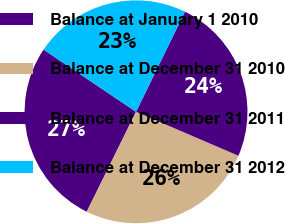Convert chart. <chart><loc_0><loc_0><loc_500><loc_500><pie_chart><fcel>Balance at January 1 2010<fcel>Balance at December 31 2010<fcel>Balance at December 31 2011<fcel>Balance at December 31 2012<nl><fcel>27.13%<fcel>25.84%<fcel>24.22%<fcel>22.82%<nl></chart> 